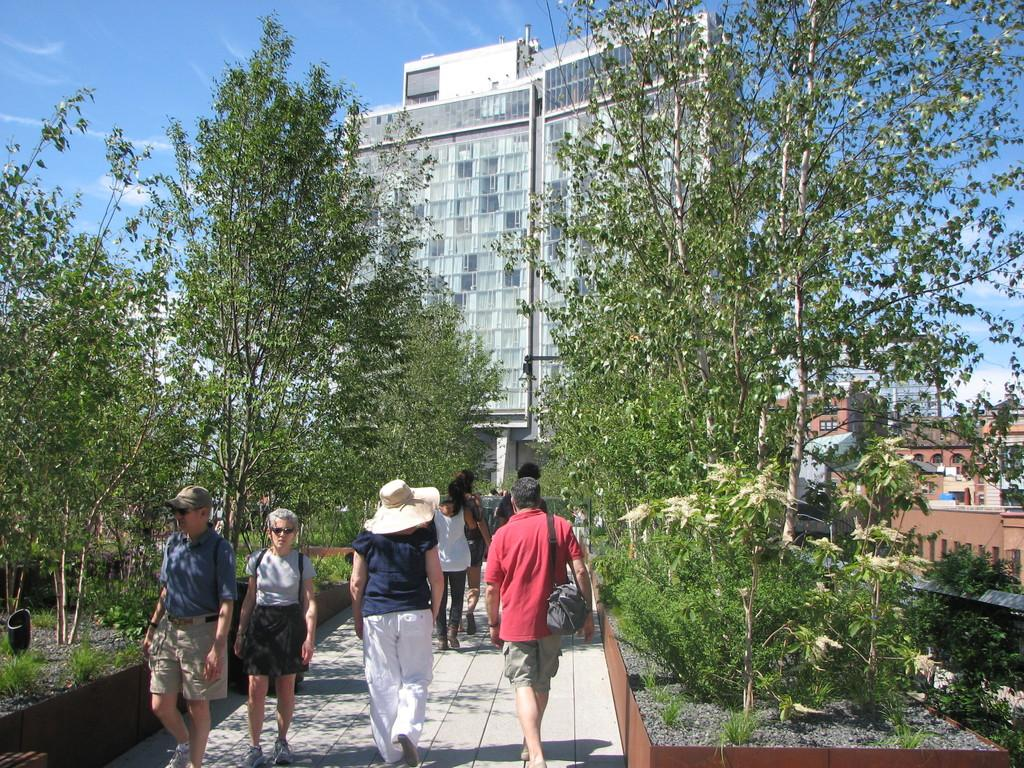What are the people in the image doing? The people in the image are walking. Can you describe the clothing of one of the people? One person is wearing a bag. What type of natural elements can be seen in the image? There are plants and trees in the image. What can be seen in the background of the image? There are buildings and the sky in the background of the image. What is the condition of the sky in the image? The sky is visible in the background of the image, and clouds are present. What type of fish can be seen swimming in the image? There are no fish present in the image; it features people walking, plants, trees, buildings, and a sky with clouds. What is the story behind the thing in the image? There is no specific "thing" mentioned in the image, and no story is associated with it. 